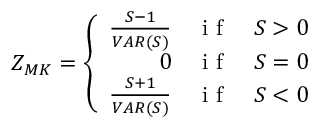Convert formula to latex. <formula><loc_0><loc_0><loc_500><loc_500>Z _ { M K } = \left \{ \begin{array} { r l l } { \frac { S - 1 } { V A R ( S ) } } & { i f } & { S > 0 } \\ { 0 } & { i f } & { S = 0 } \\ { \frac { S + 1 } { V A R ( S ) } } & { i f } & { S < 0 } \end{array}</formula> 